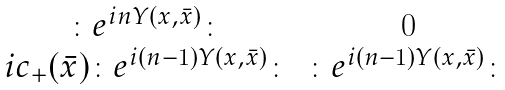Convert formula to latex. <formula><loc_0><loc_0><loc_500><loc_500>\begin{matrix} \colon e ^ { i n Y ( x , \bar { x } ) } \colon & 0 \\ i c _ { + } ( \bar { x } ) \colon e ^ { i ( n - 1 ) Y ( x , \bar { x } ) } \colon & \colon e ^ { i ( n - 1 ) Y ( x , \bar { x } ) } \colon \end{matrix}</formula> 